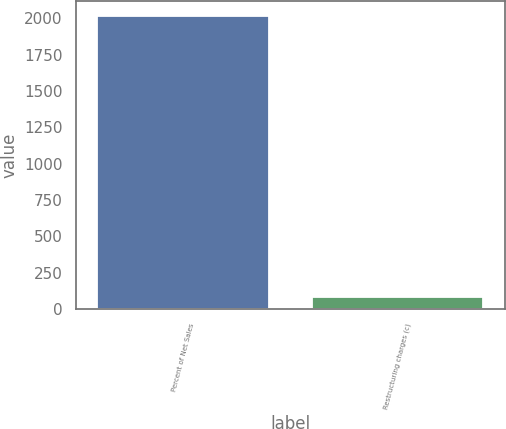<chart> <loc_0><loc_0><loc_500><loc_500><bar_chart><fcel>Percent of Net Sales<fcel>Restructuring charges (c)<nl><fcel>2018<fcel>82.7<nl></chart> 